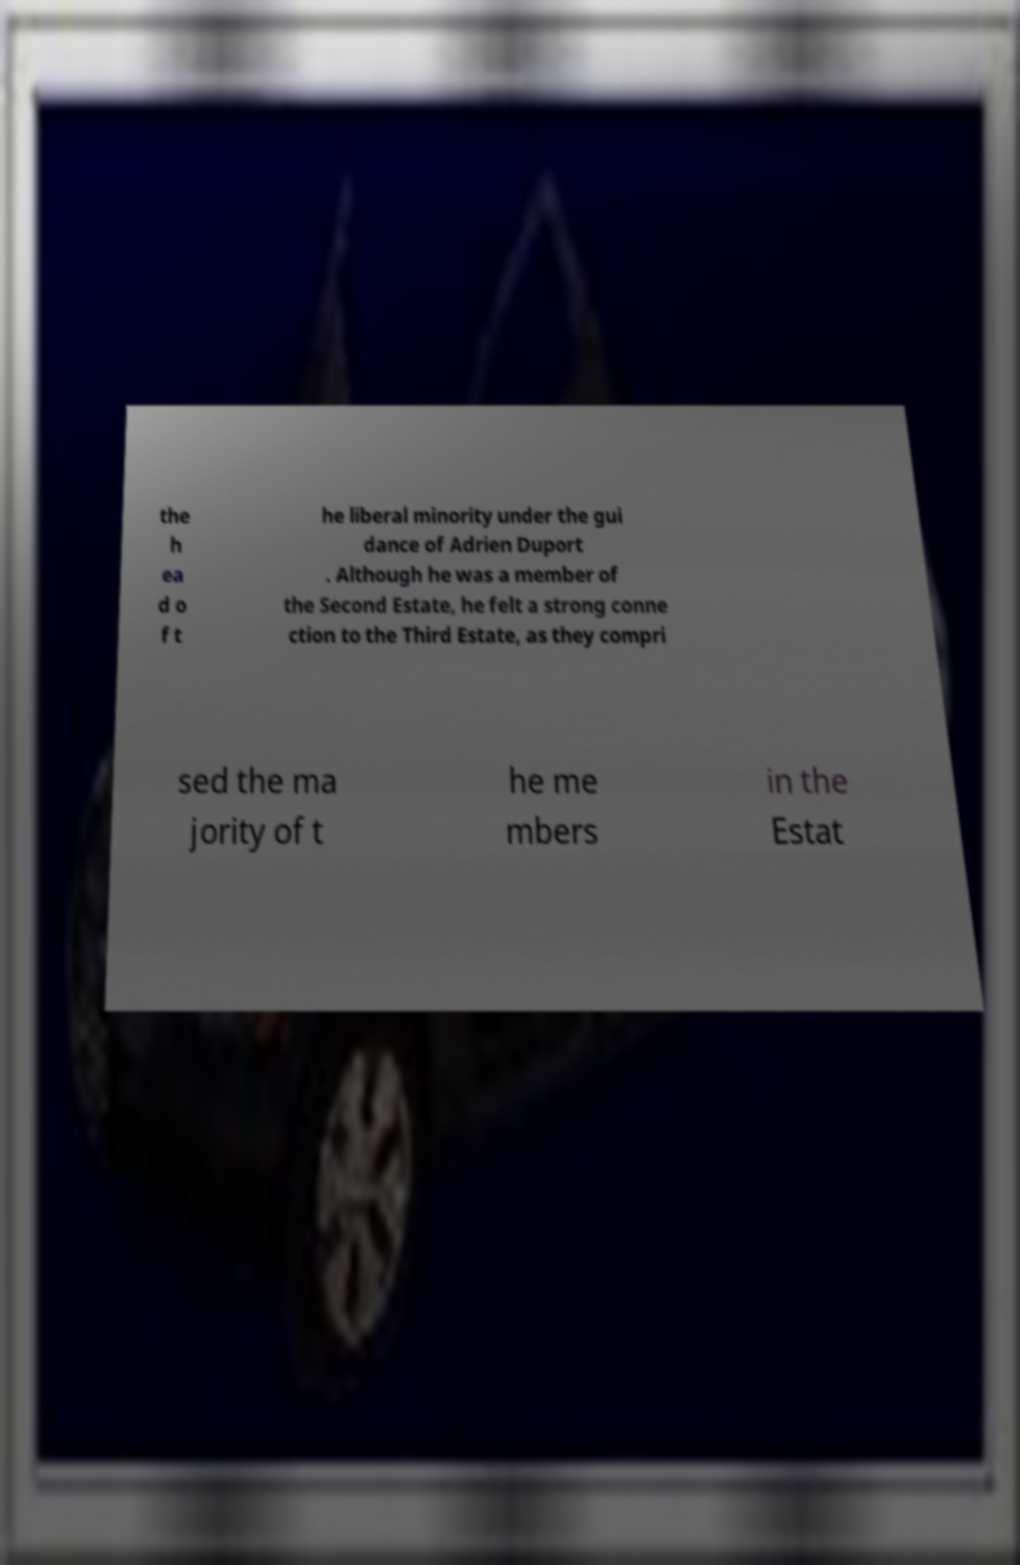Could you extract and type out the text from this image? the h ea d o f t he liberal minority under the gui dance of Adrien Duport . Although he was a member of the Second Estate, he felt a strong conne ction to the Third Estate, as they compri sed the ma jority of t he me mbers in the Estat 